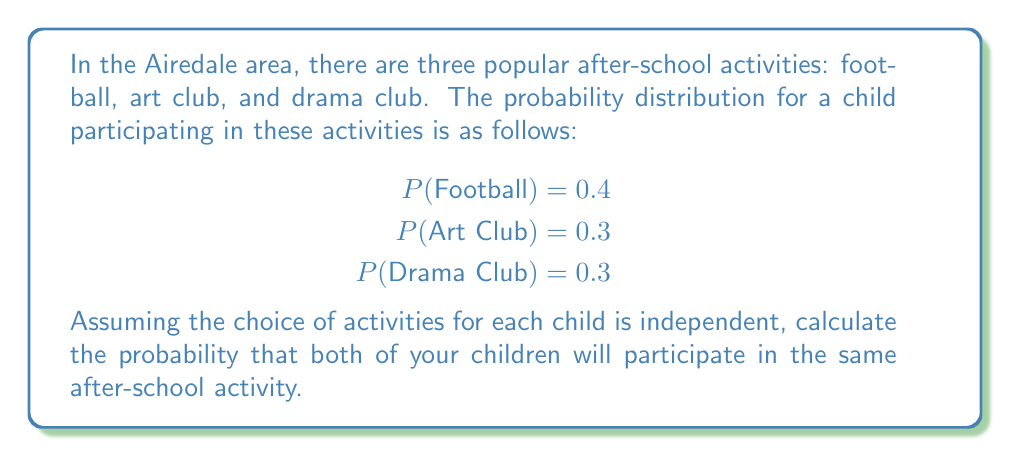Provide a solution to this math problem. To solve this problem, we'll use the concept of multivariate probability distributions:

1) First, we need to calculate the probability of both children participating in each specific activity:

   a) For Football: $P(\text{Both in Football}) = 0.4 \times 0.4 = 0.16$
   b) For Art Club: $P(\text{Both in Art Club}) = 0.3 \times 0.3 = 0.09$
   c) For Drama Club: $P(\text{Both in Drama Club}) = 0.3 \times 0.3 = 0.09$

2) The probability of both children participating in the same activity is the sum of these individual probabilities:

   $$P(\text{Same Activity}) = P(\text{Both in Football}) + P(\text{Both in Art Club}) + P(\text{Both in Drama Club})$$

3) Substituting the values:

   $$P(\text{Same Activity}) = 0.16 + 0.09 + 0.09 = 0.34$$

Therefore, the probability that both children will participate in the same after-school activity is 0.34 or 34%.
Answer: 0.34 